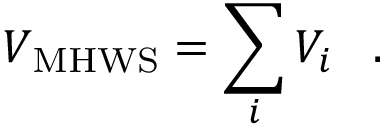<formula> <loc_0><loc_0><loc_500><loc_500>{ V _ { M H W S } } = \sum _ { i } V _ { i } \, .</formula> 